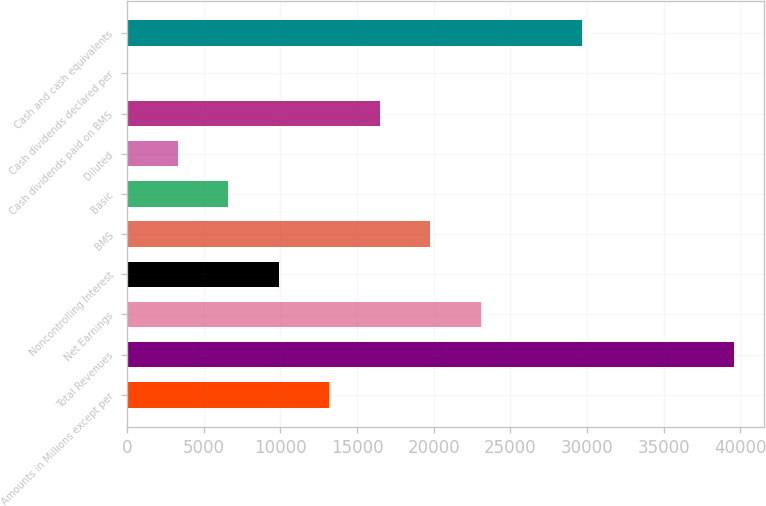<chart> <loc_0><loc_0><loc_500><loc_500><bar_chart><fcel>Amounts in Millions except per<fcel>Total Revenues<fcel>Net Earnings<fcel>Noncontrolling Interest<fcel>BMS<fcel>Basic<fcel>Diluted<fcel>Cash dividends paid on BMS<fcel>Cash dividends declared per<fcel>Cash and cash equivalents<nl><fcel>13188.8<fcel>39563.8<fcel>23079.4<fcel>9891.94<fcel>19782.5<fcel>6595.07<fcel>3298.2<fcel>16485.7<fcel>1.33<fcel>29673.2<nl></chart> 